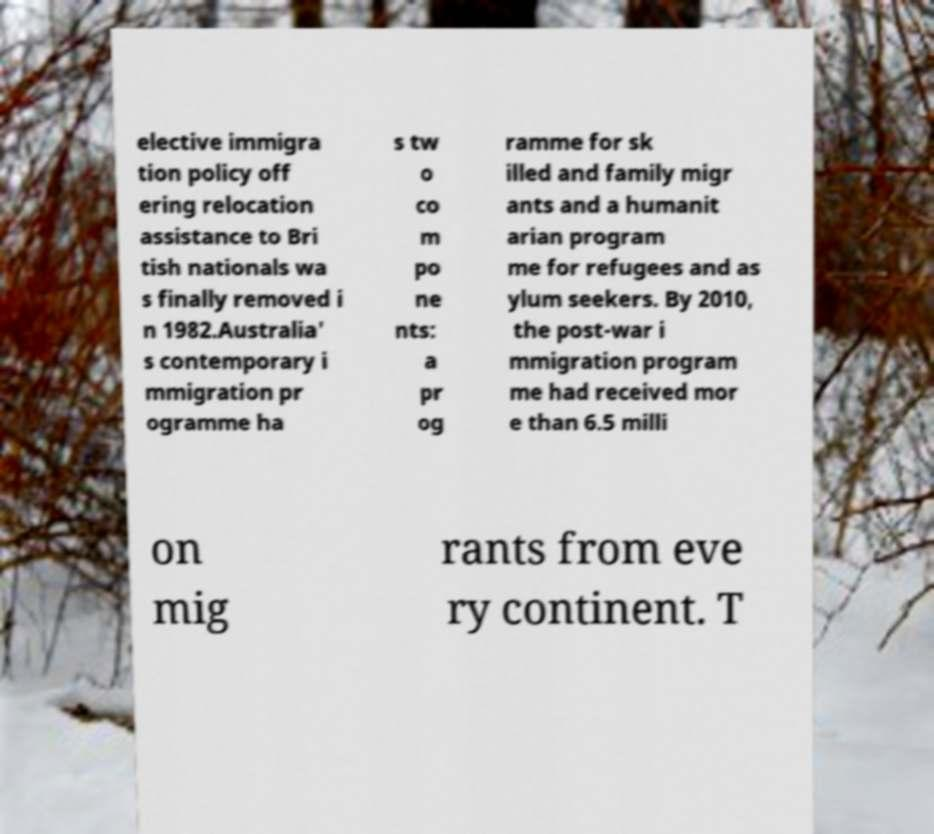Could you extract and type out the text from this image? elective immigra tion policy off ering relocation assistance to Bri tish nationals wa s finally removed i n 1982.Australia' s contemporary i mmigration pr ogramme ha s tw o co m po ne nts: a pr og ramme for sk illed and family migr ants and a humanit arian program me for refugees and as ylum seekers. By 2010, the post-war i mmigration program me had received mor e than 6.5 milli on mig rants from eve ry continent. T 